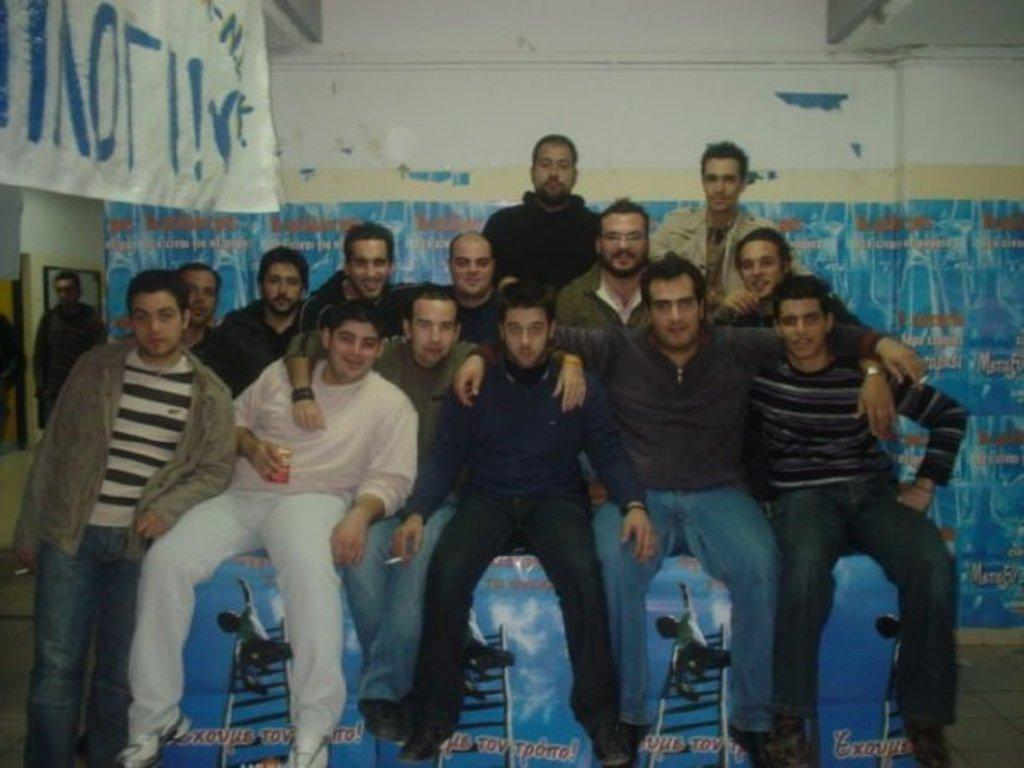What are the people in the image doing? The people in the image are sitting and standing in the middle of the image. What can be seen in the background of the image? There is a wall and banners in the background of the image. What type of beetle can be seen crawling on the banners in the image? There is no beetle present in the image; only people, a wall, and banners are visible. 